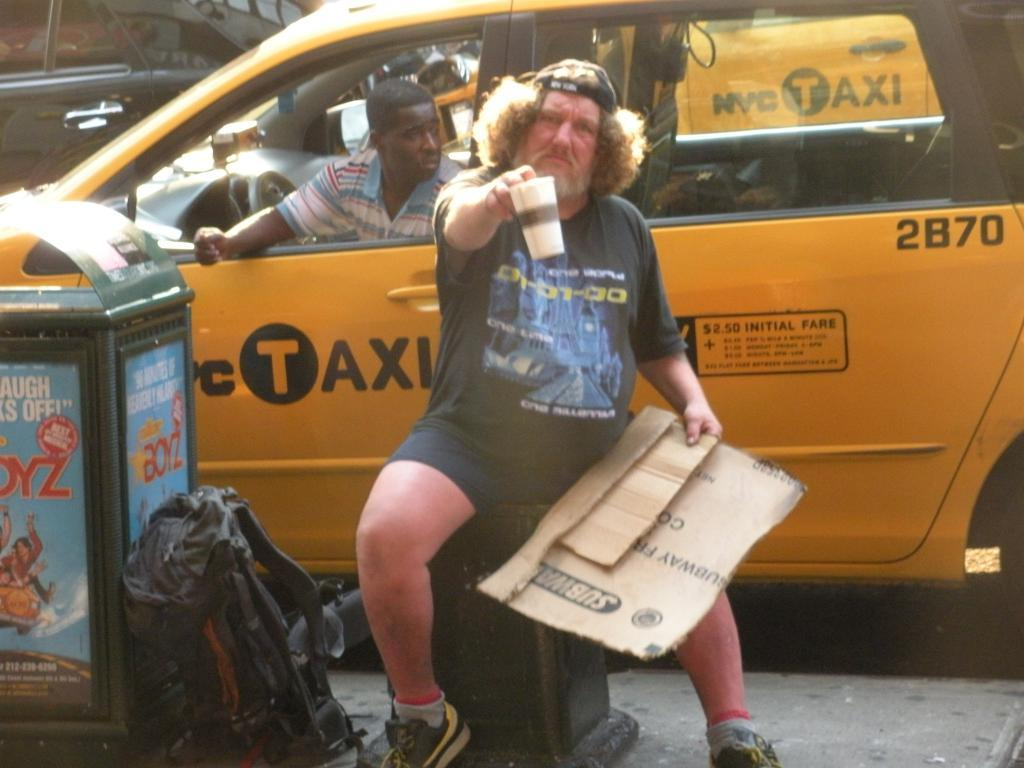<image>
Create a compact narrative representing the image presented. A man sitting next to a trash can with a yellow taxi cab behind him. 